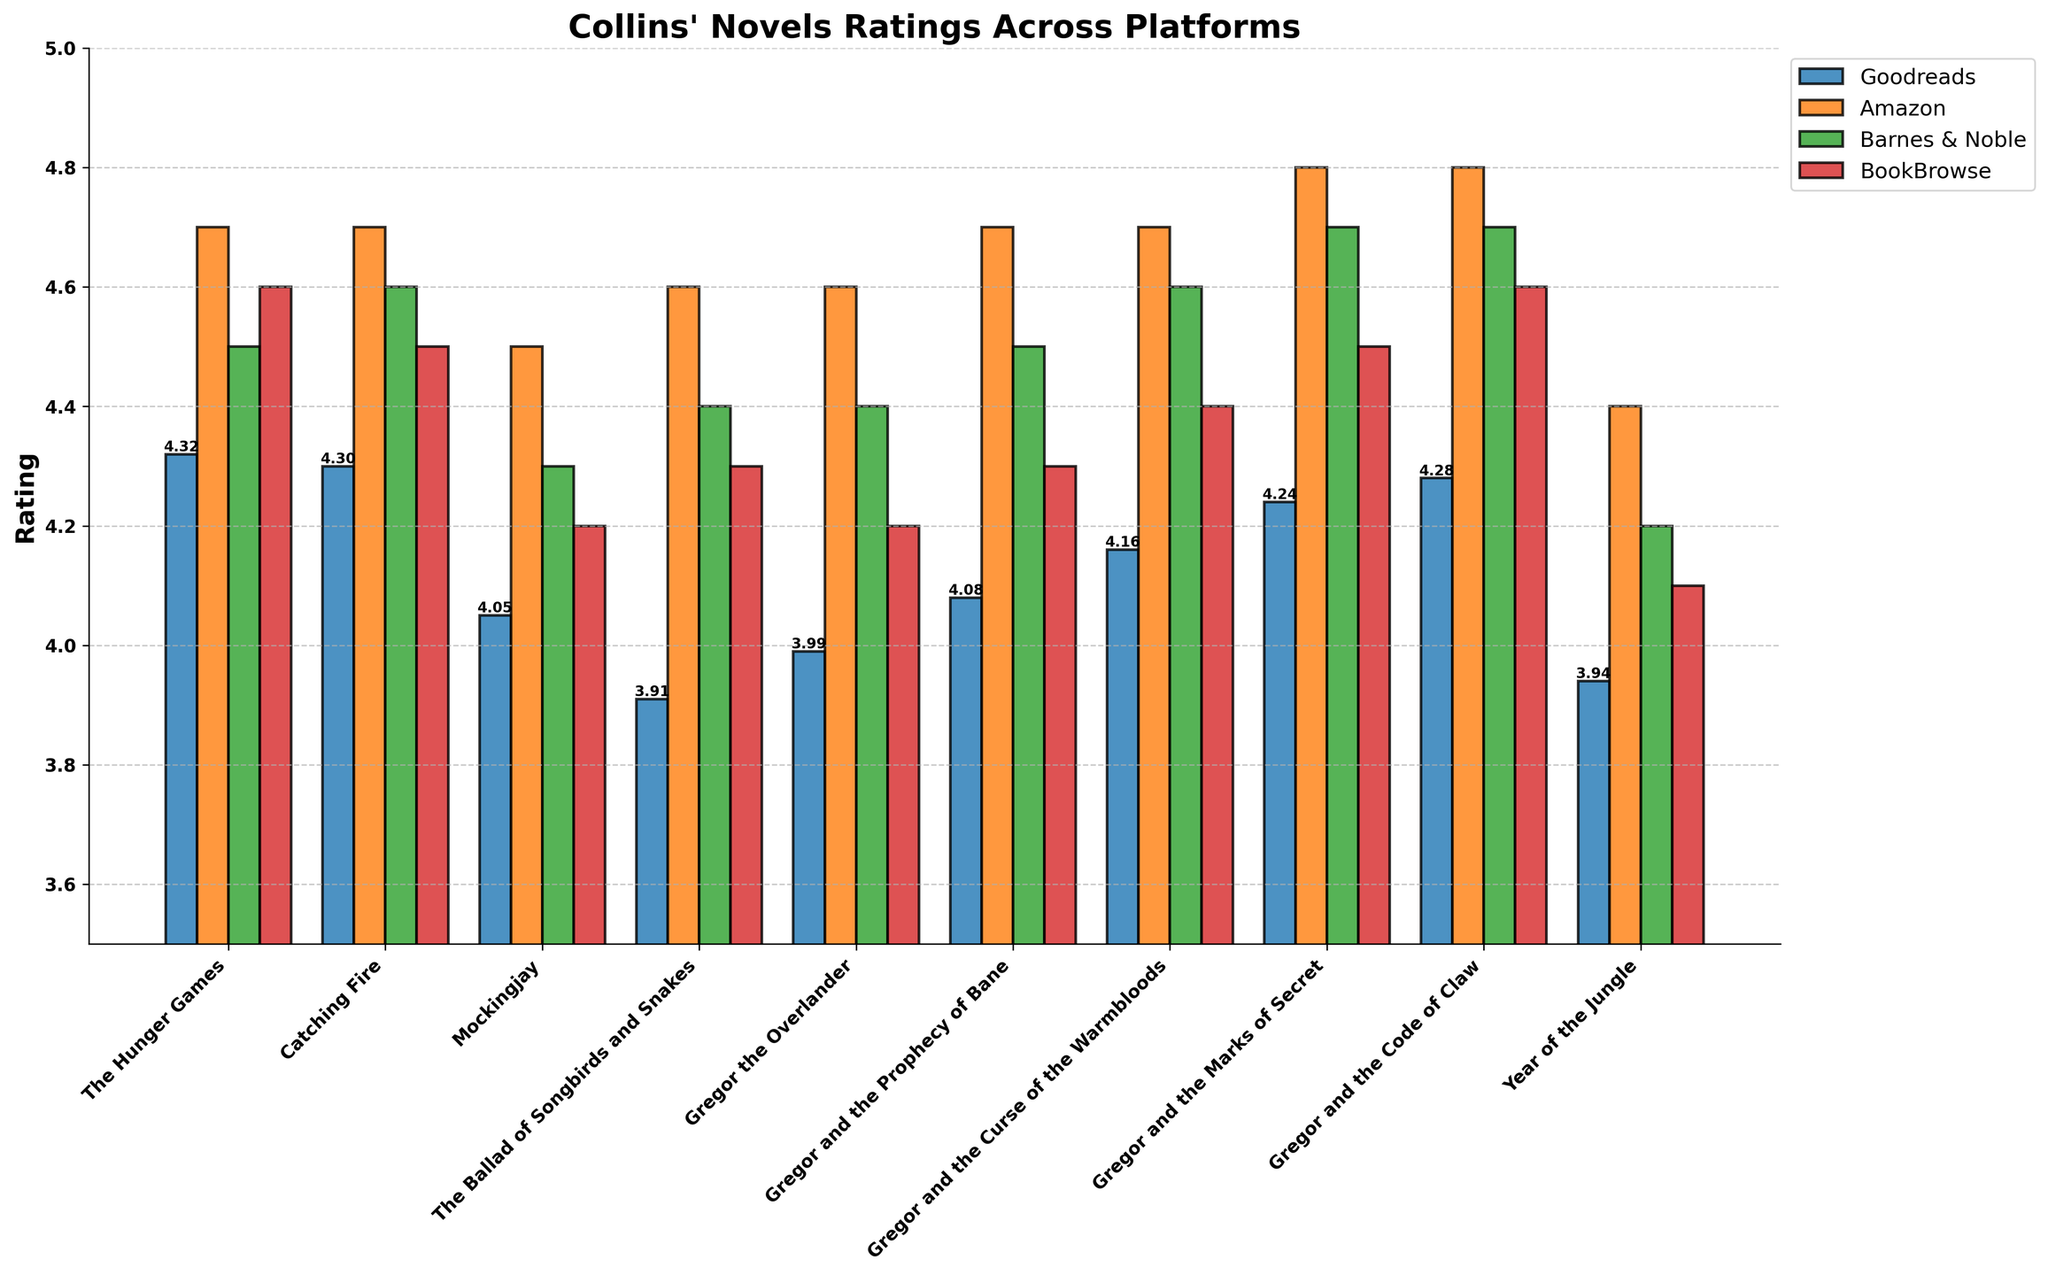Which platform gives the highest rating for "The Hunger Games"? Look for the bar representing "The Hunger Games" on each platform and identify the highest one. The highest bar is for Amazon with a rating of 4.7.
Answer: Amazon Compare the ratings for "Catching Fire" and "Mockingjay" on BookBrowse. Which one is higher? Check the "Catching Fire" and "Mockingjay" bars on BookBrowse. "Catching Fire" has a rating of 4.5, whereas "Mockingjay" has a rating of 4.2.
Answer: Catching Fire What is the average rating of "Gregor the Overlander" across all platforms? Add up all the ratings for "Gregor the Overlander" and divide by the number of platforms: (3.99 + 4.6 + 4.4 + 4.2)/4 = 4.2975.
Answer: 4.30 Which novel has the lowest rating on Goodreads? Identify the shortest bar on Goodreads. "The Ballad of Songbirds and Snakes" has the lowest rating of 3.91.
Answer: The Ballad of Songbirds and Snakes For which novel is there the widest rating range across platforms? Compare the differences between the highest and lowest ratings across platforms for each novel. "The Ballad of Songbirds and Snakes" has the widest range from 3.91 on Goodreads to 4.6 on Amazon.
Answer: The Ballad of Songbirds and Snakes What is the sum of ratings for "The Hunger Games" across Amazon and Barnes & Noble? Add the ratings of "The Hunger Games" from Amazon and Barnes & Noble: 4.7 + 4.5 = 9.2.
Answer: 9.2 Which novel has higher ratings on average: "Gregor and the Marks of Secret" or "Year of the Jungle"? Calculate the average ratings for both novels: "Gregor and the Marks of Secret" (4.24 + 4.8 + 4.7 + 4.5)/4 = 4.56; "Year of the Jungle" (3.94 + 4.4 + 4.2 + 4.1)/4 = 4.16.
Answer: Gregor and the Marks of Secret Does "Mockingjay" have equal or higher ratings on BookBrowse compared to Barnes & Noble? Compare the ratings of "Mockingjay" on BookBrowse and Barnes & Noble: 4.2 (BookBrowse) vs. 4.3 (Barnes & Noble).
Answer: No Which novel among the Gregor series got the highest rating on Amazon? Identify the novel from the Gregor series with the tallest bar on Amazon. "Gregor and the Marks of Secret" and "Gregor and the Code of Claw" both have the highest rating of 4.8 on Amazon.
Answer: Gregor and the Marks of Secret, Gregor and the Code of Claw 